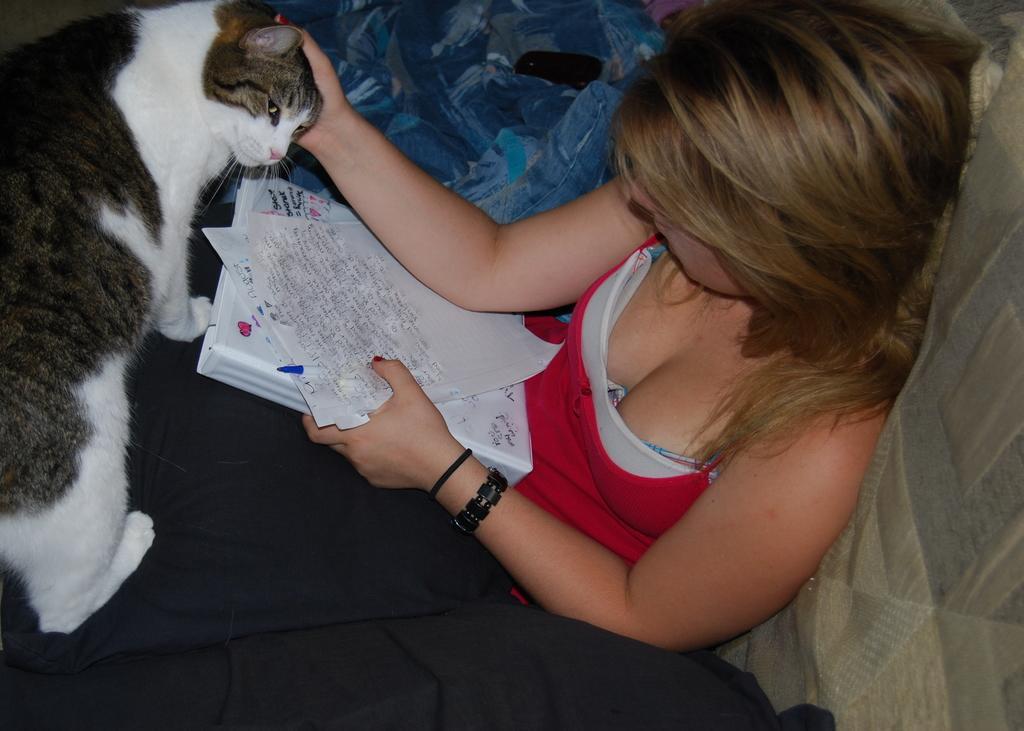How would you summarize this image in a sentence or two? In this image I see a woman who is sitting on a couch and she is holding papers, a book and a pen and she is touching a cat. 